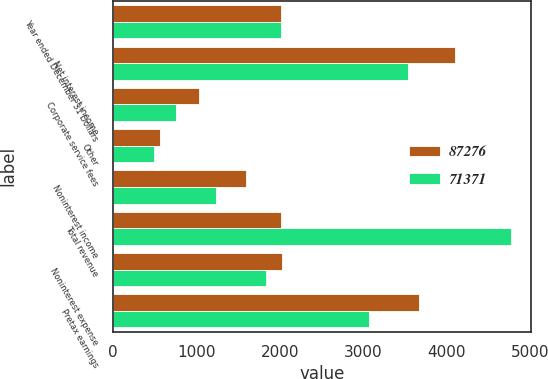Convert chart to OTSL. <chart><loc_0><loc_0><loc_500><loc_500><stacked_bar_chart><ecel><fcel>Year ended December 31 Dollars<fcel>Net interest income<fcel>Corporate service fees<fcel>Other<fcel>Noninterest income<fcel>Total revenue<fcel>Noninterest expense<fcel>Pretax earnings<nl><fcel>87276<fcel>2012<fcel>4099<fcel>1030<fcel>568<fcel>1598<fcel>2011<fcel>2028<fcel>3669<nl><fcel>71371<fcel>2011<fcel>3538<fcel>752<fcel>485<fcel>1237<fcel>4775<fcel>1832<fcel>3067<nl></chart> 